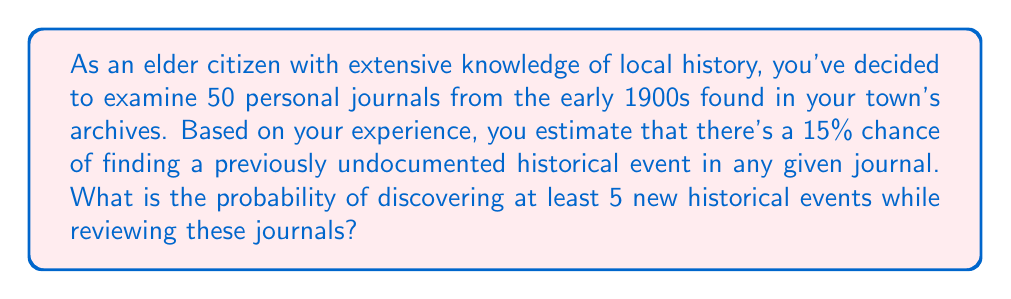Teach me how to tackle this problem. To solve this problem, we can use the binomial probability distribution. Let's break it down step-by-step:

1) We have a binomial experiment because:
   - There are a fixed number of trials (n = 50 journals)
   - Each trial has two possible outcomes (success: finding a new event, or failure: not finding one)
   - The probability of success is constant for each trial (p = 0.15)
   - The trials are independent

2) We want to find the probability of at least 5 successes, which means we need to calculate the probability of 5 or more successes.

3) Let X be the number of journals containing new historical events. We need to find:

   $P(X \geq 5) = 1 - P(X < 5) = 1 - P(X \leq 4)$

4) The probability of exactly k successes in n trials is given by the binomial probability formula:

   $P(X = k) = \binom{n}{k} p^k (1-p)^{n-k}$

   Where $\binom{n}{k}$ is the binomial coefficient.

5) We need to sum this for k = 0, 1, 2, 3, and 4:

   $P(X \leq 4) = \sum_{k=0}^{4} \binom{50}{k} (0.15)^k (0.85)^{50-k}$

6) Calculating this sum:

   $P(X \leq 4) = 0.0388 + 0.3424 + 0.1369 + 0.0316 + 0.0055 = 0.5552$

7) Therefore, the probability of at least 5 new historical events is:

   $P(X \geq 5) = 1 - P(X \leq 4) = 1 - 0.5552 = 0.4448$
Answer: The probability of discovering at least 5 new historical events while reviewing the 50 journals is approximately 0.4448 or 44.48%. 